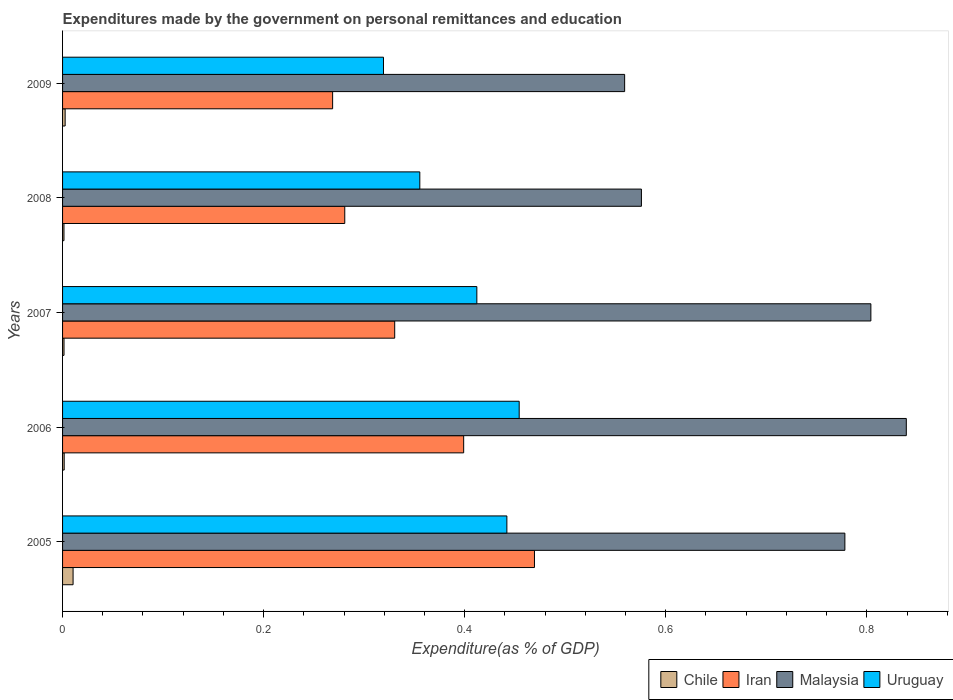How many groups of bars are there?
Keep it short and to the point. 5. Are the number of bars per tick equal to the number of legend labels?
Your answer should be very brief. Yes. Are the number of bars on each tick of the Y-axis equal?
Your answer should be very brief. Yes. How many bars are there on the 5th tick from the bottom?
Keep it short and to the point. 4. What is the label of the 1st group of bars from the top?
Your answer should be compact. 2009. What is the expenditures made by the government on personal remittances and education in Chile in 2008?
Your answer should be very brief. 0. Across all years, what is the maximum expenditures made by the government on personal remittances and education in Uruguay?
Provide a succinct answer. 0.45. Across all years, what is the minimum expenditures made by the government on personal remittances and education in Iran?
Your answer should be compact. 0.27. In which year was the expenditures made by the government on personal remittances and education in Malaysia maximum?
Provide a succinct answer. 2006. In which year was the expenditures made by the government on personal remittances and education in Malaysia minimum?
Offer a terse response. 2009. What is the total expenditures made by the government on personal remittances and education in Malaysia in the graph?
Make the answer very short. 3.56. What is the difference between the expenditures made by the government on personal remittances and education in Uruguay in 2006 and that in 2009?
Provide a succinct answer. 0.13. What is the difference between the expenditures made by the government on personal remittances and education in Uruguay in 2006 and the expenditures made by the government on personal remittances and education in Chile in 2007?
Keep it short and to the point. 0.45. What is the average expenditures made by the government on personal remittances and education in Chile per year?
Offer a very short reply. 0. In the year 2008, what is the difference between the expenditures made by the government on personal remittances and education in Malaysia and expenditures made by the government on personal remittances and education in Iran?
Your answer should be very brief. 0.3. In how many years, is the expenditures made by the government on personal remittances and education in Chile greater than 0.16 %?
Make the answer very short. 0. What is the ratio of the expenditures made by the government on personal remittances and education in Chile in 2006 to that in 2007?
Ensure brevity in your answer.  1.12. What is the difference between the highest and the second highest expenditures made by the government on personal remittances and education in Malaysia?
Ensure brevity in your answer.  0.04. What is the difference between the highest and the lowest expenditures made by the government on personal remittances and education in Iran?
Ensure brevity in your answer.  0.2. In how many years, is the expenditures made by the government on personal remittances and education in Iran greater than the average expenditures made by the government on personal remittances and education in Iran taken over all years?
Provide a short and direct response. 2. Is the sum of the expenditures made by the government on personal remittances and education in Iran in 2005 and 2008 greater than the maximum expenditures made by the government on personal remittances and education in Uruguay across all years?
Your answer should be compact. Yes. What does the 2nd bar from the top in 2007 represents?
Your answer should be compact. Malaysia. What does the 4th bar from the bottom in 2006 represents?
Provide a short and direct response. Uruguay. Is it the case that in every year, the sum of the expenditures made by the government on personal remittances and education in Malaysia and expenditures made by the government on personal remittances and education in Chile is greater than the expenditures made by the government on personal remittances and education in Uruguay?
Provide a succinct answer. Yes. How many years are there in the graph?
Keep it short and to the point. 5. Does the graph contain any zero values?
Offer a very short reply. No. Where does the legend appear in the graph?
Give a very brief answer. Bottom right. What is the title of the graph?
Ensure brevity in your answer.  Expenditures made by the government on personal remittances and education. What is the label or title of the X-axis?
Provide a short and direct response. Expenditure(as % of GDP). What is the Expenditure(as % of GDP) of Chile in 2005?
Offer a very short reply. 0.01. What is the Expenditure(as % of GDP) of Iran in 2005?
Offer a terse response. 0.47. What is the Expenditure(as % of GDP) of Malaysia in 2005?
Offer a very short reply. 0.78. What is the Expenditure(as % of GDP) of Uruguay in 2005?
Keep it short and to the point. 0.44. What is the Expenditure(as % of GDP) in Chile in 2006?
Give a very brief answer. 0. What is the Expenditure(as % of GDP) of Iran in 2006?
Offer a very short reply. 0.4. What is the Expenditure(as % of GDP) in Malaysia in 2006?
Your response must be concise. 0.84. What is the Expenditure(as % of GDP) in Uruguay in 2006?
Make the answer very short. 0.45. What is the Expenditure(as % of GDP) in Chile in 2007?
Your response must be concise. 0. What is the Expenditure(as % of GDP) of Iran in 2007?
Provide a succinct answer. 0.33. What is the Expenditure(as % of GDP) in Malaysia in 2007?
Make the answer very short. 0.8. What is the Expenditure(as % of GDP) of Uruguay in 2007?
Provide a succinct answer. 0.41. What is the Expenditure(as % of GDP) of Chile in 2008?
Offer a very short reply. 0. What is the Expenditure(as % of GDP) in Iran in 2008?
Your answer should be compact. 0.28. What is the Expenditure(as % of GDP) in Malaysia in 2008?
Your answer should be compact. 0.58. What is the Expenditure(as % of GDP) of Uruguay in 2008?
Your answer should be compact. 0.36. What is the Expenditure(as % of GDP) of Chile in 2009?
Your answer should be compact. 0. What is the Expenditure(as % of GDP) in Iran in 2009?
Your answer should be very brief. 0.27. What is the Expenditure(as % of GDP) of Malaysia in 2009?
Provide a short and direct response. 0.56. What is the Expenditure(as % of GDP) in Uruguay in 2009?
Offer a terse response. 0.32. Across all years, what is the maximum Expenditure(as % of GDP) of Chile?
Your answer should be compact. 0.01. Across all years, what is the maximum Expenditure(as % of GDP) of Iran?
Give a very brief answer. 0.47. Across all years, what is the maximum Expenditure(as % of GDP) in Malaysia?
Your response must be concise. 0.84. Across all years, what is the maximum Expenditure(as % of GDP) of Uruguay?
Keep it short and to the point. 0.45. Across all years, what is the minimum Expenditure(as % of GDP) of Chile?
Give a very brief answer. 0. Across all years, what is the minimum Expenditure(as % of GDP) of Iran?
Provide a succinct answer. 0.27. Across all years, what is the minimum Expenditure(as % of GDP) in Malaysia?
Offer a very short reply. 0.56. Across all years, what is the minimum Expenditure(as % of GDP) of Uruguay?
Your response must be concise. 0.32. What is the total Expenditure(as % of GDP) of Chile in the graph?
Your answer should be compact. 0.02. What is the total Expenditure(as % of GDP) in Iran in the graph?
Keep it short and to the point. 1.75. What is the total Expenditure(as % of GDP) in Malaysia in the graph?
Offer a very short reply. 3.56. What is the total Expenditure(as % of GDP) of Uruguay in the graph?
Your answer should be compact. 1.98. What is the difference between the Expenditure(as % of GDP) of Chile in 2005 and that in 2006?
Your answer should be very brief. 0.01. What is the difference between the Expenditure(as % of GDP) in Iran in 2005 and that in 2006?
Make the answer very short. 0.07. What is the difference between the Expenditure(as % of GDP) in Malaysia in 2005 and that in 2006?
Your answer should be compact. -0.06. What is the difference between the Expenditure(as % of GDP) in Uruguay in 2005 and that in 2006?
Your response must be concise. -0.01. What is the difference between the Expenditure(as % of GDP) of Chile in 2005 and that in 2007?
Ensure brevity in your answer.  0.01. What is the difference between the Expenditure(as % of GDP) in Iran in 2005 and that in 2007?
Your response must be concise. 0.14. What is the difference between the Expenditure(as % of GDP) in Malaysia in 2005 and that in 2007?
Give a very brief answer. -0.03. What is the difference between the Expenditure(as % of GDP) of Uruguay in 2005 and that in 2007?
Make the answer very short. 0.03. What is the difference between the Expenditure(as % of GDP) in Chile in 2005 and that in 2008?
Provide a succinct answer. 0.01. What is the difference between the Expenditure(as % of GDP) in Iran in 2005 and that in 2008?
Provide a succinct answer. 0.19. What is the difference between the Expenditure(as % of GDP) of Malaysia in 2005 and that in 2008?
Make the answer very short. 0.2. What is the difference between the Expenditure(as % of GDP) of Uruguay in 2005 and that in 2008?
Give a very brief answer. 0.09. What is the difference between the Expenditure(as % of GDP) in Chile in 2005 and that in 2009?
Give a very brief answer. 0.01. What is the difference between the Expenditure(as % of GDP) of Iran in 2005 and that in 2009?
Your answer should be compact. 0.2. What is the difference between the Expenditure(as % of GDP) in Malaysia in 2005 and that in 2009?
Provide a succinct answer. 0.22. What is the difference between the Expenditure(as % of GDP) of Uruguay in 2005 and that in 2009?
Give a very brief answer. 0.12. What is the difference between the Expenditure(as % of GDP) of Chile in 2006 and that in 2007?
Provide a succinct answer. 0. What is the difference between the Expenditure(as % of GDP) of Iran in 2006 and that in 2007?
Your response must be concise. 0.07. What is the difference between the Expenditure(as % of GDP) of Malaysia in 2006 and that in 2007?
Provide a short and direct response. 0.04. What is the difference between the Expenditure(as % of GDP) of Uruguay in 2006 and that in 2007?
Keep it short and to the point. 0.04. What is the difference between the Expenditure(as % of GDP) in Iran in 2006 and that in 2008?
Your answer should be compact. 0.12. What is the difference between the Expenditure(as % of GDP) in Malaysia in 2006 and that in 2008?
Provide a succinct answer. 0.26. What is the difference between the Expenditure(as % of GDP) of Uruguay in 2006 and that in 2008?
Ensure brevity in your answer.  0.1. What is the difference between the Expenditure(as % of GDP) of Chile in 2006 and that in 2009?
Your answer should be compact. -0. What is the difference between the Expenditure(as % of GDP) of Iran in 2006 and that in 2009?
Ensure brevity in your answer.  0.13. What is the difference between the Expenditure(as % of GDP) in Malaysia in 2006 and that in 2009?
Ensure brevity in your answer.  0.28. What is the difference between the Expenditure(as % of GDP) of Uruguay in 2006 and that in 2009?
Keep it short and to the point. 0.14. What is the difference between the Expenditure(as % of GDP) of Iran in 2007 and that in 2008?
Offer a terse response. 0.05. What is the difference between the Expenditure(as % of GDP) of Malaysia in 2007 and that in 2008?
Provide a succinct answer. 0.23. What is the difference between the Expenditure(as % of GDP) of Uruguay in 2007 and that in 2008?
Your answer should be compact. 0.06. What is the difference between the Expenditure(as % of GDP) of Chile in 2007 and that in 2009?
Offer a terse response. -0. What is the difference between the Expenditure(as % of GDP) in Iran in 2007 and that in 2009?
Ensure brevity in your answer.  0.06. What is the difference between the Expenditure(as % of GDP) in Malaysia in 2007 and that in 2009?
Give a very brief answer. 0.24. What is the difference between the Expenditure(as % of GDP) of Uruguay in 2007 and that in 2009?
Give a very brief answer. 0.09. What is the difference between the Expenditure(as % of GDP) of Chile in 2008 and that in 2009?
Offer a terse response. -0. What is the difference between the Expenditure(as % of GDP) of Iran in 2008 and that in 2009?
Your answer should be compact. 0.01. What is the difference between the Expenditure(as % of GDP) of Malaysia in 2008 and that in 2009?
Give a very brief answer. 0.02. What is the difference between the Expenditure(as % of GDP) in Uruguay in 2008 and that in 2009?
Give a very brief answer. 0.04. What is the difference between the Expenditure(as % of GDP) in Chile in 2005 and the Expenditure(as % of GDP) in Iran in 2006?
Your answer should be very brief. -0.39. What is the difference between the Expenditure(as % of GDP) in Chile in 2005 and the Expenditure(as % of GDP) in Malaysia in 2006?
Offer a very short reply. -0.83. What is the difference between the Expenditure(as % of GDP) of Chile in 2005 and the Expenditure(as % of GDP) of Uruguay in 2006?
Your answer should be very brief. -0.44. What is the difference between the Expenditure(as % of GDP) of Iran in 2005 and the Expenditure(as % of GDP) of Malaysia in 2006?
Keep it short and to the point. -0.37. What is the difference between the Expenditure(as % of GDP) in Iran in 2005 and the Expenditure(as % of GDP) in Uruguay in 2006?
Make the answer very short. 0.02. What is the difference between the Expenditure(as % of GDP) in Malaysia in 2005 and the Expenditure(as % of GDP) in Uruguay in 2006?
Your response must be concise. 0.32. What is the difference between the Expenditure(as % of GDP) of Chile in 2005 and the Expenditure(as % of GDP) of Iran in 2007?
Give a very brief answer. -0.32. What is the difference between the Expenditure(as % of GDP) of Chile in 2005 and the Expenditure(as % of GDP) of Malaysia in 2007?
Your response must be concise. -0.79. What is the difference between the Expenditure(as % of GDP) in Chile in 2005 and the Expenditure(as % of GDP) in Uruguay in 2007?
Provide a succinct answer. -0.4. What is the difference between the Expenditure(as % of GDP) of Iran in 2005 and the Expenditure(as % of GDP) of Malaysia in 2007?
Make the answer very short. -0.33. What is the difference between the Expenditure(as % of GDP) of Iran in 2005 and the Expenditure(as % of GDP) of Uruguay in 2007?
Your answer should be very brief. 0.06. What is the difference between the Expenditure(as % of GDP) of Malaysia in 2005 and the Expenditure(as % of GDP) of Uruguay in 2007?
Make the answer very short. 0.37. What is the difference between the Expenditure(as % of GDP) in Chile in 2005 and the Expenditure(as % of GDP) in Iran in 2008?
Your response must be concise. -0.27. What is the difference between the Expenditure(as % of GDP) in Chile in 2005 and the Expenditure(as % of GDP) in Malaysia in 2008?
Make the answer very short. -0.57. What is the difference between the Expenditure(as % of GDP) of Chile in 2005 and the Expenditure(as % of GDP) of Uruguay in 2008?
Provide a succinct answer. -0.34. What is the difference between the Expenditure(as % of GDP) in Iran in 2005 and the Expenditure(as % of GDP) in Malaysia in 2008?
Provide a succinct answer. -0.11. What is the difference between the Expenditure(as % of GDP) of Iran in 2005 and the Expenditure(as % of GDP) of Uruguay in 2008?
Your response must be concise. 0.11. What is the difference between the Expenditure(as % of GDP) in Malaysia in 2005 and the Expenditure(as % of GDP) in Uruguay in 2008?
Ensure brevity in your answer.  0.42. What is the difference between the Expenditure(as % of GDP) in Chile in 2005 and the Expenditure(as % of GDP) in Iran in 2009?
Provide a short and direct response. -0.26. What is the difference between the Expenditure(as % of GDP) in Chile in 2005 and the Expenditure(as % of GDP) in Malaysia in 2009?
Offer a terse response. -0.55. What is the difference between the Expenditure(as % of GDP) in Chile in 2005 and the Expenditure(as % of GDP) in Uruguay in 2009?
Offer a very short reply. -0.31. What is the difference between the Expenditure(as % of GDP) of Iran in 2005 and the Expenditure(as % of GDP) of Malaysia in 2009?
Your answer should be very brief. -0.09. What is the difference between the Expenditure(as % of GDP) in Iran in 2005 and the Expenditure(as % of GDP) in Uruguay in 2009?
Your answer should be compact. 0.15. What is the difference between the Expenditure(as % of GDP) of Malaysia in 2005 and the Expenditure(as % of GDP) of Uruguay in 2009?
Provide a short and direct response. 0.46. What is the difference between the Expenditure(as % of GDP) in Chile in 2006 and the Expenditure(as % of GDP) in Iran in 2007?
Keep it short and to the point. -0.33. What is the difference between the Expenditure(as % of GDP) of Chile in 2006 and the Expenditure(as % of GDP) of Malaysia in 2007?
Offer a very short reply. -0.8. What is the difference between the Expenditure(as % of GDP) in Chile in 2006 and the Expenditure(as % of GDP) in Uruguay in 2007?
Ensure brevity in your answer.  -0.41. What is the difference between the Expenditure(as % of GDP) in Iran in 2006 and the Expenditure(as % of GDP) in Malaysia in 2007?
Make the answer very short. -0.41. What is the difference between the Expenditure(as % of GDP) of Iran in 2006 and the Expenditure(as % of GDP) of Uruguay in 2007?
Ensure brevity in your answer.  -0.01. What is the difference between the Expenditure(as % of GDP) in Malaysia in 2006 and the Expenditure(as % of GDP) in Uruguay in 2007?
Provide a short and direct response. 0.43. What is the difference between the Expenditure(as % of GDP) of Chile in 2006 and the Expenditure(as % of GDP) of Iran in 2008?
Offer a very short reply. -0.28. What is the difference between the Expenditure(as % of GDP) of Chile in 2006 and the Expenditure(as % of GDP) of Malaysia in 2008?
Offer a terse response. -0.57. What is the difference between the Expenditure(as % of GDP) of Chile in 2006 and the Expenditure(as % of GDP) of Uruguay in 2008?
Provide a succinct answer. -0.35. What is the difference between the Expenditure(as % of GDP) of Iran in 2006 and the Expenditure(as % of GDP) of Malaysia in 2008?
Ensure brevity in your answer.  -0.18. What is the difference between the Expenditure(as % of GDP) in Iran in 2006 and the Expenditure(as % of GDP) in Uruguay in 2008?
Offer a terse response. 0.04. What is the difference between the Expenditure(as % of GDP) of Malaysia in 2006 and the Expenditure(as % of GDP) of Uruguay in 2008?
Your response must be concise. 0.48. What is the difference between the Expenditure(as % of GDP) in Chile in 2006 and the Expenditure(as % of GDP) in Iran in 2009?
Keep it short and to the point. -0.27. What is the difference between the Expenditure(as % of GDP) of Chile in 2006 and the Expenditure(as % of GDP) of Malaysia in 2009?
Make the answer very short. -0.56. What is the difference between the Expenditure(as % of GDP) of Chile in 2006 and the Expenditure(as % of GDP) of Uruguay in 2009?
Your answer should be compact. -0.32. What is the difference between the Expenditure(as % of GDP) of Iran in 2006 and the Expenditure(as % of GDP) of Malaysia in 2009?
Your answer should be very brief. -0.16. What is the difference between the Expenditure(as % of GDP) in Iran in 2006 and the Expenditure(as % of GDP) in Uruguay in 2009?
Your answer should be very brief. 0.08. What is the difference between the Expenditure(as % of GDP) of Malaysia in 2006 and the Expenditure(as % of GDP) of Uruguay in 2009?
Provide a short and direct response. 0.52. What is the difference between the Expenditure(as % of GDP) of Chile in 2007 and the Expenditure(as % of GDP) of Iran in 2008?
Ensure brevity in your answer.  -0.28. What is the difference between the Expenditure(as % of GDP) of Chile in 2007 and the Expenditure(as % of GDP) of Malaysia in 2008?
Your response must be concise. -0.57. What is the difference between the Expenditure(as % of GDP) in Chile in 2007 and the Expenditure(as % of GDP) in Uruguay in 2008?
Offer a terse response. -0.35. What is the difference between the Expenditure(as % of GDP) of Iran in 2007 and the Expenditure(as % of GDP) of Malaysia in 2008?
Offer a terse response. -0.25. What is the difference between the Expenditure(as % of GDP) in Iran in 2007 and the Expenditure(as % of GDP) in Uruguay in 2008?
Offer a very short reply. -0.03. What is the difference between the Expenditure(as % of GDP) of Malaysia in 2007 and the Expenditure(as % of GDP) of Uruguay in 2008?
Give a very brief answer. 0.45. What is the difference between the Expenditure(as % of GDP) of Chile in 2007 and the Expenditure(as % of GDP) of Iran in 2009?
Offer a very short reply. -0.27. What is the difference between the Expenditure(as % of GDP) of Chile in 2007 and the Expenditure(as % of GDP) of Malaysia in 2009?
Provide a succinct answer. -0.56. What is the difference between the Expenditure(as % of GDP) in Chile in 2007 and the Expenditure(as % of GDP) in Uruguay in 2009?
Ensure brevity in your answer.  -0.32. What is the difference between the Expenditure(as % of GDP) in Iran in 2007 and the Expenditure(as % of GDP) in Malaysia in 2009?
Provide a short and direct response. -0.23. What is the difference between the Expenditure(as % of GDP) of Iran in 2007 and the Expenditure(as % of GDP) of Uruguay in 2009?
Ensure brevity in your answer.  0.01. What is the difference between the Expenditure(as % of GDP) of Malaysia in 2007 and the Expenditure(as % of GDP) of Uruguay in 2009?
Your answer should be very brief. 0.48. What is the difference between the Expenditure(as % of GDP) of Chile in 2008 and the Expenditure(as % of GDP) of Iran in 2009?
Give a very brief answer. -0.27. What is the difference between the Expenditure(as % of GDP) of Chile in 2008 and the Expenditure(as % of GDP) of Malaysia in 2009?
Give a very brief answer. -0.56. What is the difference between the Expenditure(as % of GDP) in Chile in 2008 and the Expenditure(as % of GDP) in Uruguay in 2009?
Offer a terse response. -0.32. What is the difference between the Expenditure(as % of GDP) of Iran in 2008 and the Expenditure(as % of GDP) of Malaysia in 2009?
Offer a terse response. -0.28. What is the difference between the Expenditure(as % of GDP) in Iran in 2008 and the Expenditure(as % of GDP) in Uruguay in 2009?
Give a very brief answer. -0.04. What is the difference between the Expenditure(as % of GDP) in Malaysia in 2008 and the Expenditure(as % of GDP) in Uruguay in 2009?
Give a very brief answer. 0.26. What is the average Expenditure(as % of GDP) in Chile per year?
Make the answer very short. 0. What is the average Expenditure(as % of GDP) in Iran per year?
Make the answer very short. 0.35. What is the average Expenditure(as % of GDP) of Malaysia per year?
Offer a terse response. 0.71. What is the average Expenditure(as % of GDP) in Uruguay per year?
Ensure brevity in your answer.  0.4. In the year 2005, what is the difference between the Expenditure(as % of GDP) of Chile and Expenditure(as % of GDP) of Iran?
Ensure brevity in your answer.  -0.46. In the year 2005, what is the difference between the Expenditure(as % of GDP) in Chile and Expenditure(as % of GDP) in Malaysia?
Your answer should be compact. -0.77. In the year 2005, what is the difference between the Expenditure(as % of GDP) in Chile and Expenditure(as % of GDP) in Uruguay?
Make the answer very short. -0.43. In the year 2005, what is the difference between the Expenditure(as % of GDP) in Iran and Expenditure(as % of GDP) in Malaysia?
Provide a succinct answer. -0.31. In the year 2005, what is the difference between the Expenditure(as % of GDP) of Iran and Expenditure(as % of GDP) of Uruguay?
Ensure brevity in your answer.  0.03. In the year 2005, what is the difference between the Expenditure(as % of GDP) in Malaysia and Expenditure(as % of GDP) in Uruguay?
Your response must be concise. 0.34. In the year 2006, what is the difference between the Expenditure(as % of GDP) in Chile and Expenditure(as % of GDP) in Iran?
Keep it short and to the point. -0.4. In the year 2006, what is the difference between the Expenditure(as % of GDP) of Chile and Expenditure(as % of GDP) of Malaysia?
Offer a very short reply. -0.84. In the year 2006, what is the difference between the Expenditure(as % of GDP) of Chile and Expenditure(as % of GDP) of Uruguay?
Offer a terse response. -0.45. In the year 2006, what is the difference between the Expenditure(as % of GDP) in Iran and Expenditure(as % of GDP) in Malaysia?
Your answer should be very brief. -0.44. In the year 2006, what is the difference between the Expenditure(as % of GDP) of Iran and Expenditure(as % of GDP) of Uruguay?
Ensure brevity in your answer.  -0.06. In the year 2006, what is the difference between the Expenditure(as % of GDP) in Malaysia and Expenditure(as % of GDP) in Uruguay?
Your answer should be very brief. 0.39. In the year 2007, what is the difference between the Expenditure(as % of GDP) in Chile and Expenditure(as % of GDP) in Iran?
Ensure brevity in your answer.  -0.33. In the year 2007, what is the difference between the Expenditure(as % of GDP) in Chile and Expenditure(as % of GDP) in Malaysia?
Offer a terse response. -0.8. In the year 2007, what is the difference between the Expenditure(as % of GDP) of Chile and Expenditure(as % of GDP) of Uruguay?
Provide a short and direct response. -0.41. In the year 2007, what is the difference between the Expenditure(as % of GDP) in Iran and Expenditure(as % of GDP) in Malaysia?
Ensure brevity in your answer.  -0.47. In the year 2007, what is the difference between the Expenditure(as % of GDP) in Iran and Expenditure(as % of GDP) in Uruguay?
Your response must be concise. -0.08. In the year 2007, what is the difference between the Expenditure(as % of GDP) in Malaysia and Expenditure(as % of GDP) in Uruguay?
Your answer should be very brief. 0.39. In the year 2008, what is the difference between the Expenditure(as % of GDP) of Chile and Expenditure(as % of GDP) of Iran?
Ensure brevity in your answer.  -0.28. In the year 2008, what is the difference between the Expenditure(as % of GDP) of Chile and Expenditure(as % of GDP) of Malaysia?
Make the answer very short. -0.57. In the year 2008, what is the difference between the Expenditure(as % of GDP) in Chile and Expenditure(as % of GDP) in Uruguay?
Your answer should be very brief. -0.35. In the year 2008, what is the difference between the Expenditure(as % of GDP) of Iran and Expenditure(as % of GDP) of Malaysia?
Make the answer very short. -0.3. In the year 2008, what is the difference between the Expenditure(as % of GDP) of Iran and Expenditure(as % of GDP) of Uruguay?
Your answer should be compact. -0.07. In the year 2008, what is the difference between the Expenditure(as % of GDP) in Malaysia and Expenditure(as % of GDP) in Uruguay?
Provide a succinct answer. 0.22. In the year 2009, what is the difference between the Expenditure(as % of GDP) of Chile and Expenditure(as % of GDP) of Iran?
Your answer should be compact. -0.27. In the year 2009, what is the difference between the Expenditure(as % of GDP) of Chile and Expenditure(as % of GDP) of Malaysia?
Offer a terse response. -0.56. In the year 2009, what is the difference between the Expenditure(as % of GDP) in Chile and Expenditure(as % of GDP) in Uruguay?
Keep it short and to the point. -0.32. In the year 2009, what is the difference between the Expenditure(as % of GDP) of Iran and Expenditure(as % of GDP) of Malaysia?
Your answer should be compact. -0.29. In the year 2009, what is the difference between the Expenditure(as % of GDP) of Iran and Expenditure(as % of GDP) of Uruguay?
Provide a succinct answer. -0.05. In the year 2009, what is the difference between the Expenditure(as % of GDP) of Malaysia and Expenditure(as % of GDP) of Uruguay?
Your response must be concise. 0.24. What is the ratio of the Expenditure(as % of GDP) of Chile in 2005 to that in 2006?
Ensure brevity in your answer.  6.47. What is the ratio of the Expenditure(as % of GDP) of Iran in 2005 to that in 2006?
Ensure brevity in your answer.  1.18. What is the ratio of the Expenditure(as % of GDP) of Malaysia in 2005 to that in 2006?
Your response must be concise. 0.93. What is the ratio of the Expenditure(as % of GDP) of Uruguay in 2005 to that in 2006?
Provide a succinct answer. 0.97. What is the ratio of the Expenditure(as % of GDP) in Chile in 2005 to that in 2007?
Your answer should be very brief. 7.23. What is the ratio of the Expenditure(as % of GDP) of Iran in 2005 to that in 2007?
Ensure brevity in your answer.  1.42. What is the ratio of the Expenditure(as % of GDP) in Malaysia in 2005 to that in 2007?
Ensure brevity in your answer.  0.97. What is the ratio of the Expenditure(as % of GDP) of Uruguay in 2005 to that in 2007?
Offer a very short reply. 1.07. What is the ratio of the Expenditure(as % of GDP) of Chile in 2005 to that in 2008?
Make the answer very short. 7.51. What is the ratio of the Expenditure(as % of GDP) in Iran in 2005 to that in 2008?
Provide a succinct answer. 1.67. What is the ratio of the Expenditure(as % of GDP) of Malaysia in 2005 to that in 2008?
Offer a very short reply. 1.35. What is the ratio of the Expenditure(as % of GDP) in Uruguay in 2005 to that in 2008?
Make the answer very short. 1.24. What is the ratio of the Expenditure(as % of GDP) of Chile in 2005 to that in 2009?
Provide a short and direct response. 4.08. What is the ratio of the Expenditure(as % of GDP) of Iran in 2005 to that in 2009?
Make the answer very short. 1.75. What is the ratio of the Expenditure(as % of GDP) in Malaysia in 2005 to that in 2009?
Provide a short and direct response. 1.39. What is the ratio of the Expenditure(as % of GDP) of Uruguay in 2005 to that in 2009?
Your response must be concise. 1.38. What is the ratio of the Expenditure(as % of GDP) in Chile in 2006 to that in 2007?
Provide a succinct answer. 1.12. What is the ratio of the Expenditure(as % of GDP) in Iran in 2006 to that in 2007?
Offer a very short reply. 1.21. What is the ratio of the Expenditure(as % of GDP) in Malaysia in 2006 to that in 2007?
Make the answer very short. 1.04. What is the ratio of the Expenditure(as % of GDP) of Uruguay in 2006 to that in 2007?
Make the answer very short. 1.1. What is the ratio of the Expenditure(as % of GDP) of Chile in 2006 to that in 2008?
Offer a terse response. 1.16. What is the ratio of the Expenditure(as % of GDP) in Iran in 2006 to that in 2008?
Give a very brief answer. 1.42. What is the ratio of the Expenditure(as % of GDP) of Malaysia in 2006 to that in 2008?
Ensure brevity in your answer.  1.46. What is the ratio of the Expenditure(as % of GDP) of Uruguay in 2006 to that in 2008?
Provide a succinct answer. 1.28. What is the ratio of the Expenditure(as % of GDP) in Chile in 2006 to that in 2009?
Keep it short and to the point. 0.63. What is the ratio of the Expenditure(as % of GDP) in Iran in 2006 to that in 2009?
Provide a short and direct response. 1.49. What is the ratio of the Expenditure(as % of GDP) in Malaysia in 2006 to that in 2009?
Your answer should be very brief. 1.5. What is the ratio of the Expenditure(as % of GDP) in Uruguay in 2006 to that in 2009?
Offer a very short reply. 1.42. What is the ratio of the Expenditure(as % of GDP) in Chile in 2007 to that in 2008?
Your answer should be very brief. 1.04. What is the ratio of the Expenditure(as % of GDP) in Iran in 2007 to that in 2008?
Give a very brief answer. 1.18. What is the ratio of the Expenditure(as % of GDP) of Malaysia in 2007 to that in 2008?
Make the answer very short. 1.4. What is the ratio of the Expenditure(as % of GDP) in Uruguay in 2007 to that in 2008?
Your answer should be very brief. 1.16. What is the ratio of the Expenditure(as % of GDP) in Chile in 2007 to that in 2009?
Your answer should be very brief. 0.56. What is the ratio of the Expenditure(as % of GDP) in Iran in 2007 to that in 2009?
Make the answer very short. 1.23. What is the ratio of the Expenditure(as % of GDP) in Malaysia in 2007 to that in 2009?
Provide a succinct answer. 1.44. What is the ratio of the Expenditure(as % of GDP) in Uruguay in 2007 to that in 2009?
Keep it short and to the point. 1.29. What is the ratio of the Expenditure(as % of GDP) in Chile in 2008 to that in 2009?
Offer a terse response. 0.54. What is the ratio of the Expenditure(as % of GDP) of Iran in 2008 to that in 2009?
Provide a short and direct response. 1.04. What is the ratio of the Expenditure(as % of GDP) of Malaysia in 2008 to that in 2009?
Offer a terse response. 1.03. What is the ratio of the Expenditure(as % of GDP) of Uruguay in 2008 to that in 2009?
Your response must be concise. 1.11. What is the difference between the highest and the second highest Expenditure(as % of GDP) of Chile?
Give a very brief answer. 0.01. What is the difference between the highest and the second highest Expenditure(as % of GDP) in Iran?
Keep it short and to the point. 0.07. What is the difference between the highest and the second highest Expenditure(as % of GDP) of Malaysia?
Keep it short and to the point. 0.04. What is the difference between the highest and the second highest Expenditure(as % of GDP) of Uruguay?
Make the answer very short. 0.01. What is the difference between the highest and the lowest Expenditure(as % of GDP) in Chile?
Your response must be concise. 0.01. What is the difference between the highest and the lowest Expenditure(as % of GDP) in Iran?
Keep it short and to the point. 0.2. What is the difference between the highest and the lowest Expenditure(as % of GDP) in Malaysia?
Provide a short and direct response. 0.28. What is the difference between the highest and the lowest Expenditure(as % of GDP) of Uruguay?
Offer a very short reply. 0.14. 